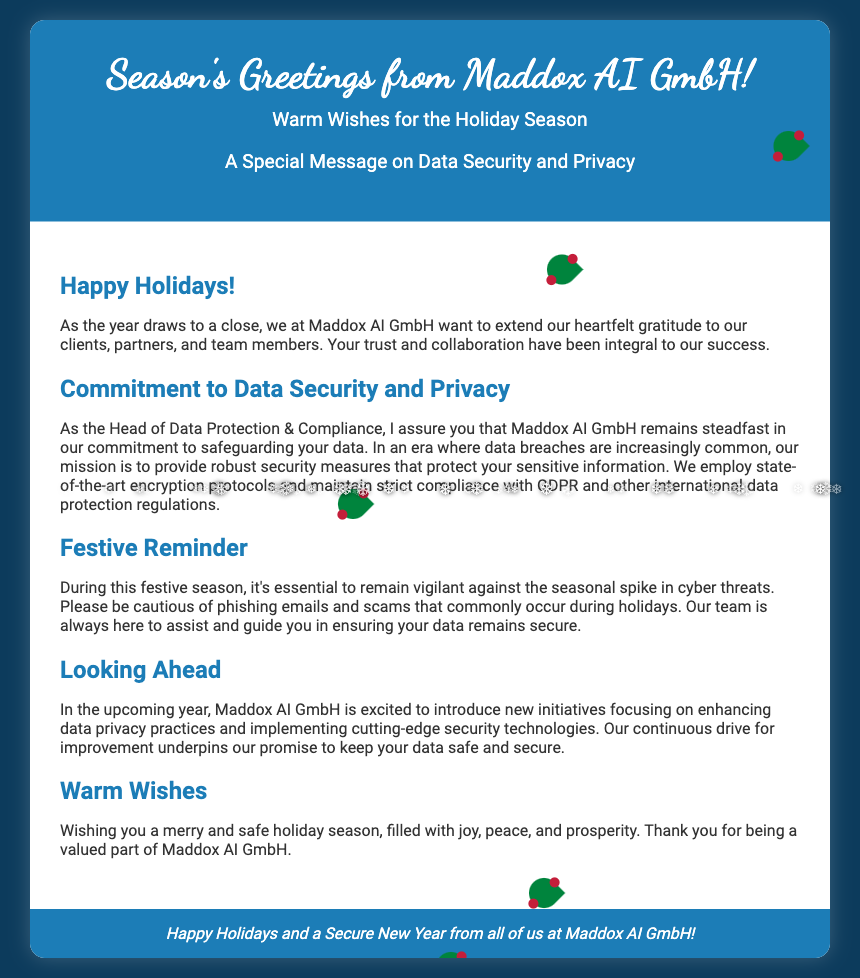What is the title of the greeting card? The title is prominently displayed in the header section of the card, which reads "Season's Greetings from Maddox AI GmbH!"
Answer: Season's Greetings from Maddox AI GmbH! What is mentioned as the company's commitment? There is a clear statement regarding the company's dedication to data security and privacy within the content section.
Answer: Commitment to Data Security and Privacy How many sections are there in the content? The content of the card is divided into five distinct sections, each with its own title.
Answer: Five What does the footer say? The footer contains a seasonal greeting that summarizes the message of the card.
Answer: Happy Holidays and a Secure New Year from all of us at Maddox AI GmbH! What is the main color scheme used in the card? The card uses a combination of white and shades of blue, particularly a specific shade identified in the header.
Answer: Blue and white Which seasonal threats should recipients be vigilant about? The message warns recipients about specific online dangers prevalent during holiday times.
Answer: Cyber threats What type of document is this? The overall purpose and structure of the content indicate its purpose as a seasonal greeting.
Answer: Greeting card How does the card encourage recipients regarding their data? The card implies an ongoing partnership aimed at reinforcing data security and compliance.
Answer: Assurance of data security 